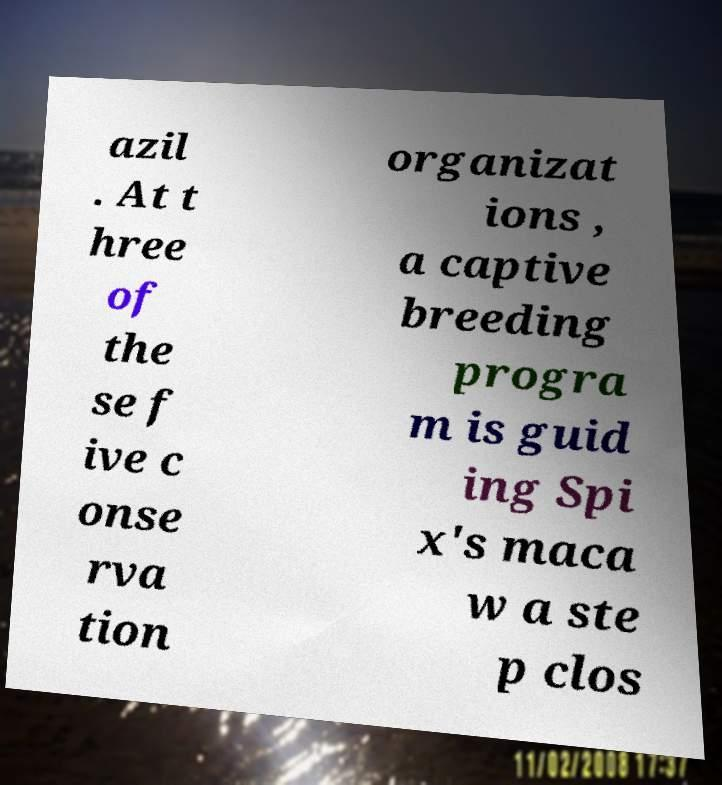Could you extract and type out the text from this image? azil . At t hree of the se f ive c onse rva tion organizat ions , a captive breeding progra m is guid ing Spi x's maca w a ste p clos 